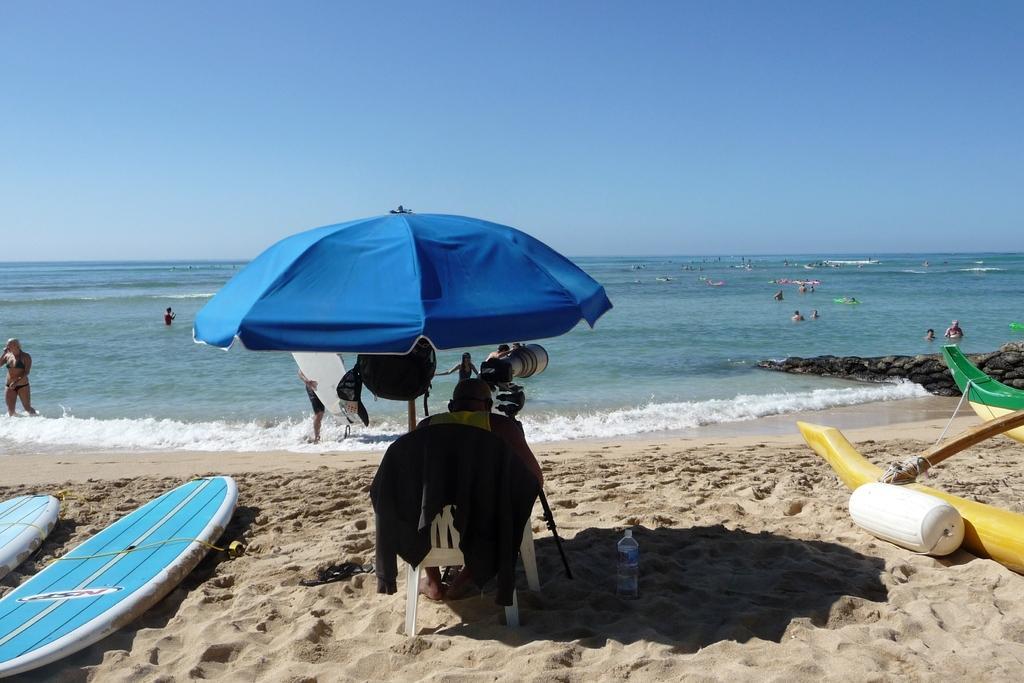Please provide a concise description of this image. This image is taken in the beach. In this image we can see the surfing boards and also some object in the sand. We can also see a person sitting on the chair under the tent. There is also a water bottle. We can also see many people in the water. Sky is also visible. 